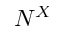<formula> <loc_0><loc_0><loc_500><loc_500>N ^ { X }</formula> 